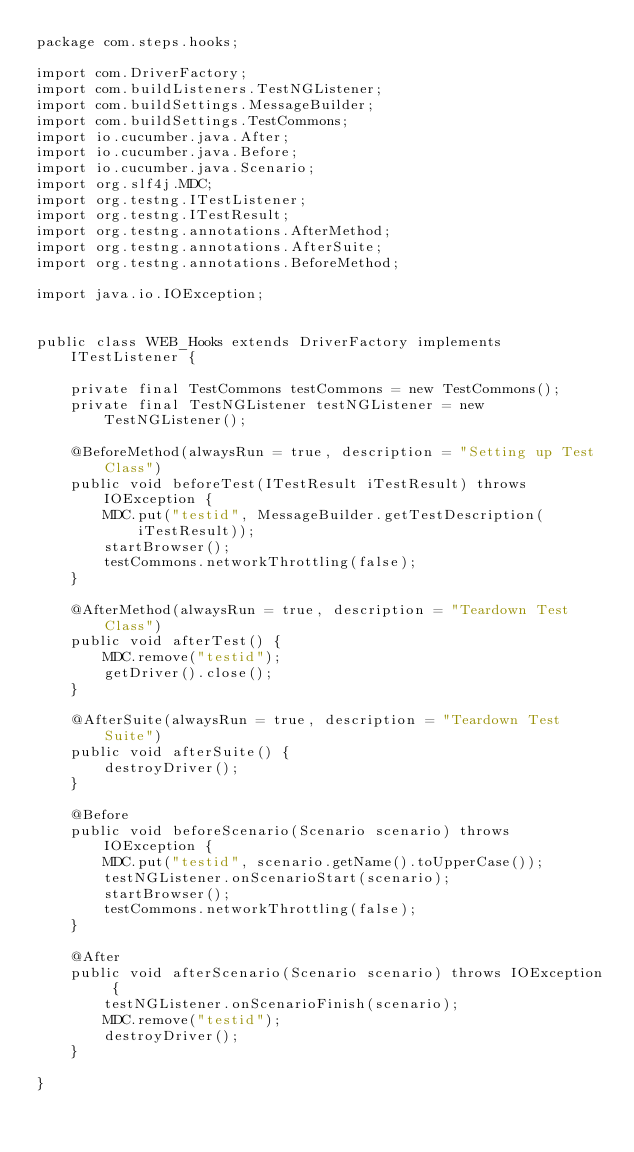Convert code to text. <code><loc_0><loc_0><loc_500><loc_500><_Java_>package com.steps.hooks;

import com.DriverFactory;
import com.buildListeners.TestNGListener;
import com.buildSettings.MessageBuilder;
import com.buildSettings.TestCommons;
import io.cucumber.java.After;
import io.cucumber.java.Before;
import io.cucumber.java.Scenario;
import org.slf4j.MDC;
import org.testng.ITestListener;
import org.testng.ITestResult;
import org.testng.annotations.AfterMethod;
import org.testng.annotations.AfterSuite;
import org.testng.annotations.BeforeMethod;

import java.io.IOException;


public class WEB_Hooks extends DriverFactory implements ITestListener {

    private final TestCommons testCommons = new TestCommons();
    private final TestNGListener testNGListener = new TestNGListener();

    @BeforeMethod(alwaysRun = true, description = "Setting up Test Class")
    public void beforeTest(ITestResult iTestResult) throws IOException {
        MDC.put("testid", MessageBuilder.getTestDescription(iTestResult));
        startBrowser();
        testCommons.networkThrottling(false);
    }

    @AfterMethod(alwaysRun = true, description = "Teardown Test Class")
    public void afterTest() {
        MDC.remove("testid");
        getDriver().close();
    }

    @AfterSuite(alwaysRun = true, description = "Teardown Test Suite")
    public void afterSuite() {
        destroyDriver();
    }

    @Before
    public void beforeScenario(Scenario scenario) throws IOException {
        MDC.put("testid", scenario.getName().toUpperCase());
        testNGListener.onScenarioStart(scenario);
        startBrowser();
        testCommons.networkThrottling(false);
    }

    @After
    public void afterScenario(Scenario scenario) throws IOException {
        testNGListener.onScenarioFinish(scenario);
        MDC.remove("testid");
        destroyDriver();
    }

}</code> 